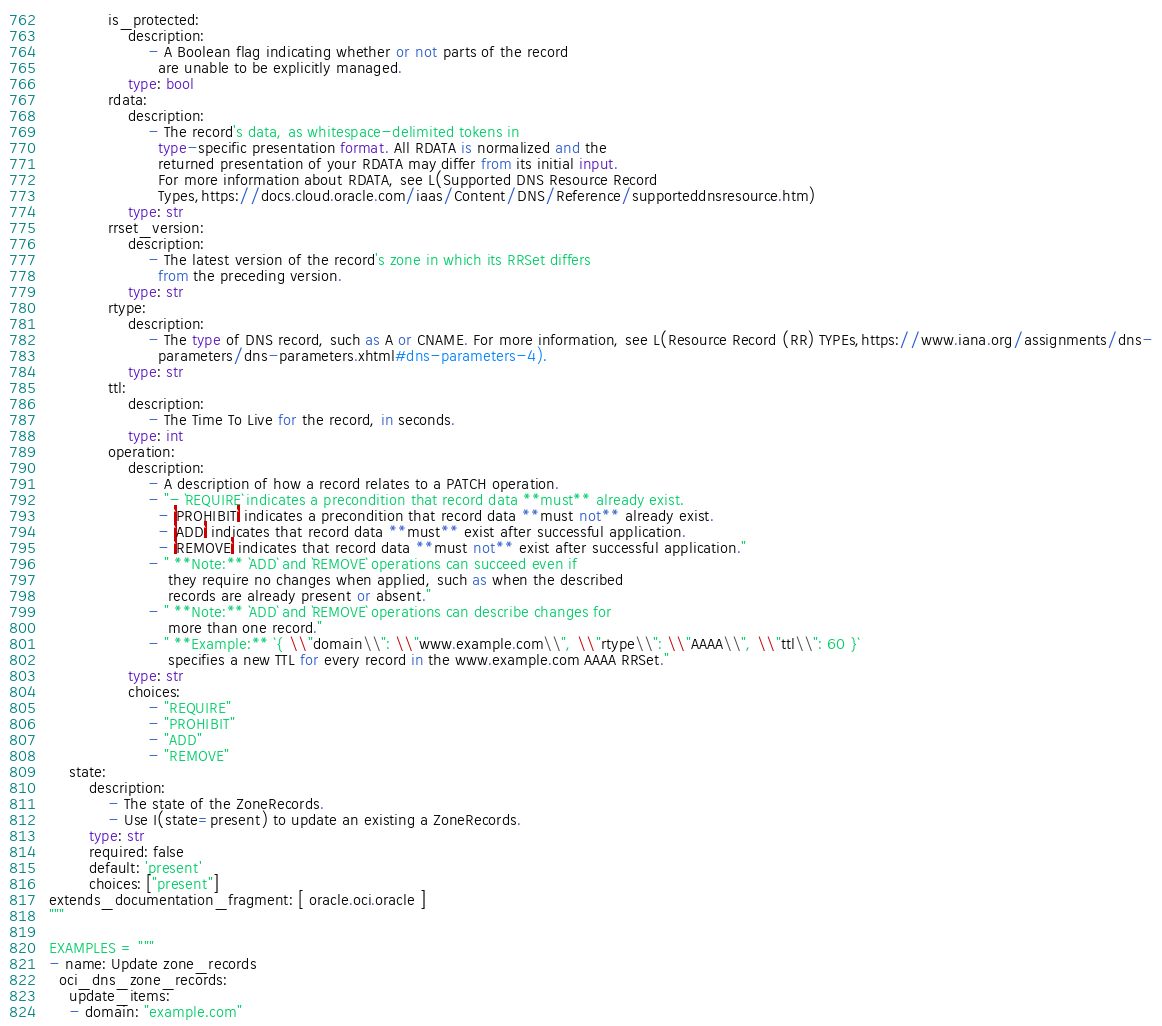Convert code to text. <code><loc_0><loc_0><loc_500><loc_500><_Python_>            is_protected:
                description:
                    - A Boolean flag indicating whether or not parts of the record
                      are unable to be explicitly managed.
                type: bool
            rdata:
                description:
                    - The record's data, as whitespace-delimited tokens in
                      type-specific presentation format. All RDATA is normalized and the
                      returned presentation of your RDATA may differ from its initial input.
                      For more information about RDATA, see L(Supported DNS Resource Record
                      Types,https://docs.cloud.oracle.com/iaas/Content/DNS/Reference/supporteddnsresource.htm)
                type: str
            rrset_version:
                description:
                    - The latest version of the record's zone in which its RRSet differs
                      from the preceding version.
                type: str
            rtype:
                description:
                    - The type of DNS record, such as A or CNAME. For more information, see L(Resource Record (RR) TYPEs,https://www.iana.org/assignments/dns-
                      parameters/dns-parameters.xhtml#dns-parameters-4).
                type: str
            ttl:
                description:
                    - The Time To Live for the record, in seconds.
                type: int
            operation:
                description:
                    - A description of how a record relates to a PATCH operation.
                    - "- `REQUIRE` indicates a precondition that record data **must** already exist.
                      - `PROHIBIT` indicates a precondition that record data **must not** already exist.
                      - `ADD` indicates that record data **must** exist after successful application.
                      - `REMOVE` indicates that record data **must not** exist after successful application."
                    - " **Note:** `ADD` and `REMOVE` operations can succeed even if
                        they require no changes when applied, such as when the described
                        records are already present or absent."
                    - " **Note:** `ADD` and `REMOVE` operations can describe changes for
                        more than one record."
                    - " **Example:** `{ \\"domain\\": \\"www.example.com\\", \\"rtype\\": \\"AAAA\\", \\"ttl\\": 60 }`
                        specifies a new TTL for every record in the www.example.com AAAA RRSet."
                type: str
                choices:
                    - "REQUIRE"
                    - "PROHIBIT"
                    - "ADD"
                    - "REMOVE"
    state:
        description:
            - The state of the ZoneRecords.
            - Use I(state=present) to update an existing a ZoneRecords.
        type: str
        required: false
        default: 'present'
        choices: ["present"]
extends_documentation_fragment: [ oracle.oci.oracle ]
"""

EXAMPLES = """
- name: Update zone_records
  oci_dns_zone_records:
    update_items:
    - domain: "example.com"</code> 